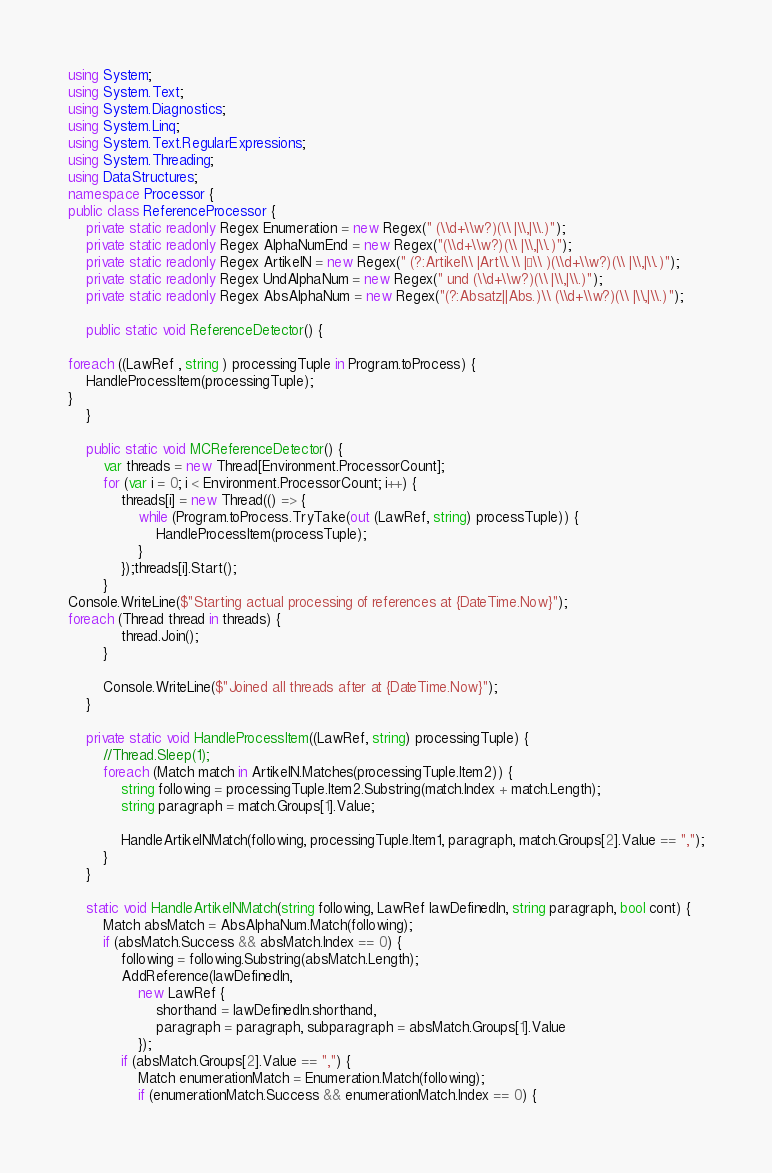Convert code to text. <code><loc_0><loc_0><loc_500><loc_500><_C#_>using System;
using System.Text;
using System.Diagnostics;
using System.Linq;
using System.Text.RegularExpressions;
using System.Threading;
using DataStructures;
namespace Processor {
public class ReferenceProcessor {
	private static readonly Regex Enumeration = new Regex(" (\\d+\\w?)(\\ |\\,|\\.)");
	private static readonly Regex AlphaNumEnd = new Regex("(\\d+\\w?)(\\ |\\,|\\.)");
	private static readonly Regex ArtikelN = new Regex(" (?:Artikel\\ |Art\\.\\ |§\\ )(\\d+\\w?)(\\ |\\,|\\.)");
	private static readonly Regex UndAlphaNum = new Regex(" und (\\d+\\w?)(\\ |\\,|\\.)");
	private static readonly Regex AbsAlphaNum = new Regex("(?:Absatz||Abs.)\\ (\\d+\\w?)(\\ |\\,|\\.)");

	public static void ReferenceDetector() {

foreach ((LawRef , string ) processingTuple in Program.toProcess) {
	HandleProcessItem(processingTuple);
}
	}

	public static void MCReferenceDetector() {
		var threads = new Thread[Environment.ProcessorCount];
		for (var i = 0; i < Environment.ProcessorCount; i++) {
			threads[i] = new Thread(() => {
				while (Program.toProcess.TryTake(out (LawRef, string) processTuple)) {
					HandleProcessItem(processTuple);
				}
			});threads[i].Start();
		}
Console.WriteLine($"Starting actual processing of references at {DateTime.Now}");
foreach (Thread thread in threads) {
			thread.Join();
		}

		Console.WriteLine($"Joined all threads after at {DateTime.Now}");
	}

	private static void HandleProcessItem((LawRef, string) processingTuple) {
		//Thread.Sleep(1);
		foreach (Match match in ArtikelN.Matches(processingTuple.Item2)) {
			string following = processingTuple.Item2.Substring(match.Index + match.Length);
			string paragraph = match.Groups[1].Value;

			HandleArtikelNMatch(following, processingTuple.Item1, paragraph, match.Groups[2].Value == ",");
		}
	}

	static void HandleArtikelNMatch(string following, LawRef lawDefinedIn, string paragraph, bool cont) {
		Match absMatch = AbsAlphaNum.Match(following);
		if (absMatch.Success && absMatch.Index == 0) {
			following = following.Substring(absMatch.Length);
			AddReference(lawDefinedIn,
				new LawRef {
					shorthand = lawDefinedIn.shorthand,
					paragraph = paragraph, subparagraph = absMatch.Groups[1].Value
				});
			if (absMatch.Groups[2].Value == ",") {
				Match enumerationMatch = Enumeration.Match(following);
				if (enumerationMatch.Success && enumerationMatch.Index == 0) {</code> 